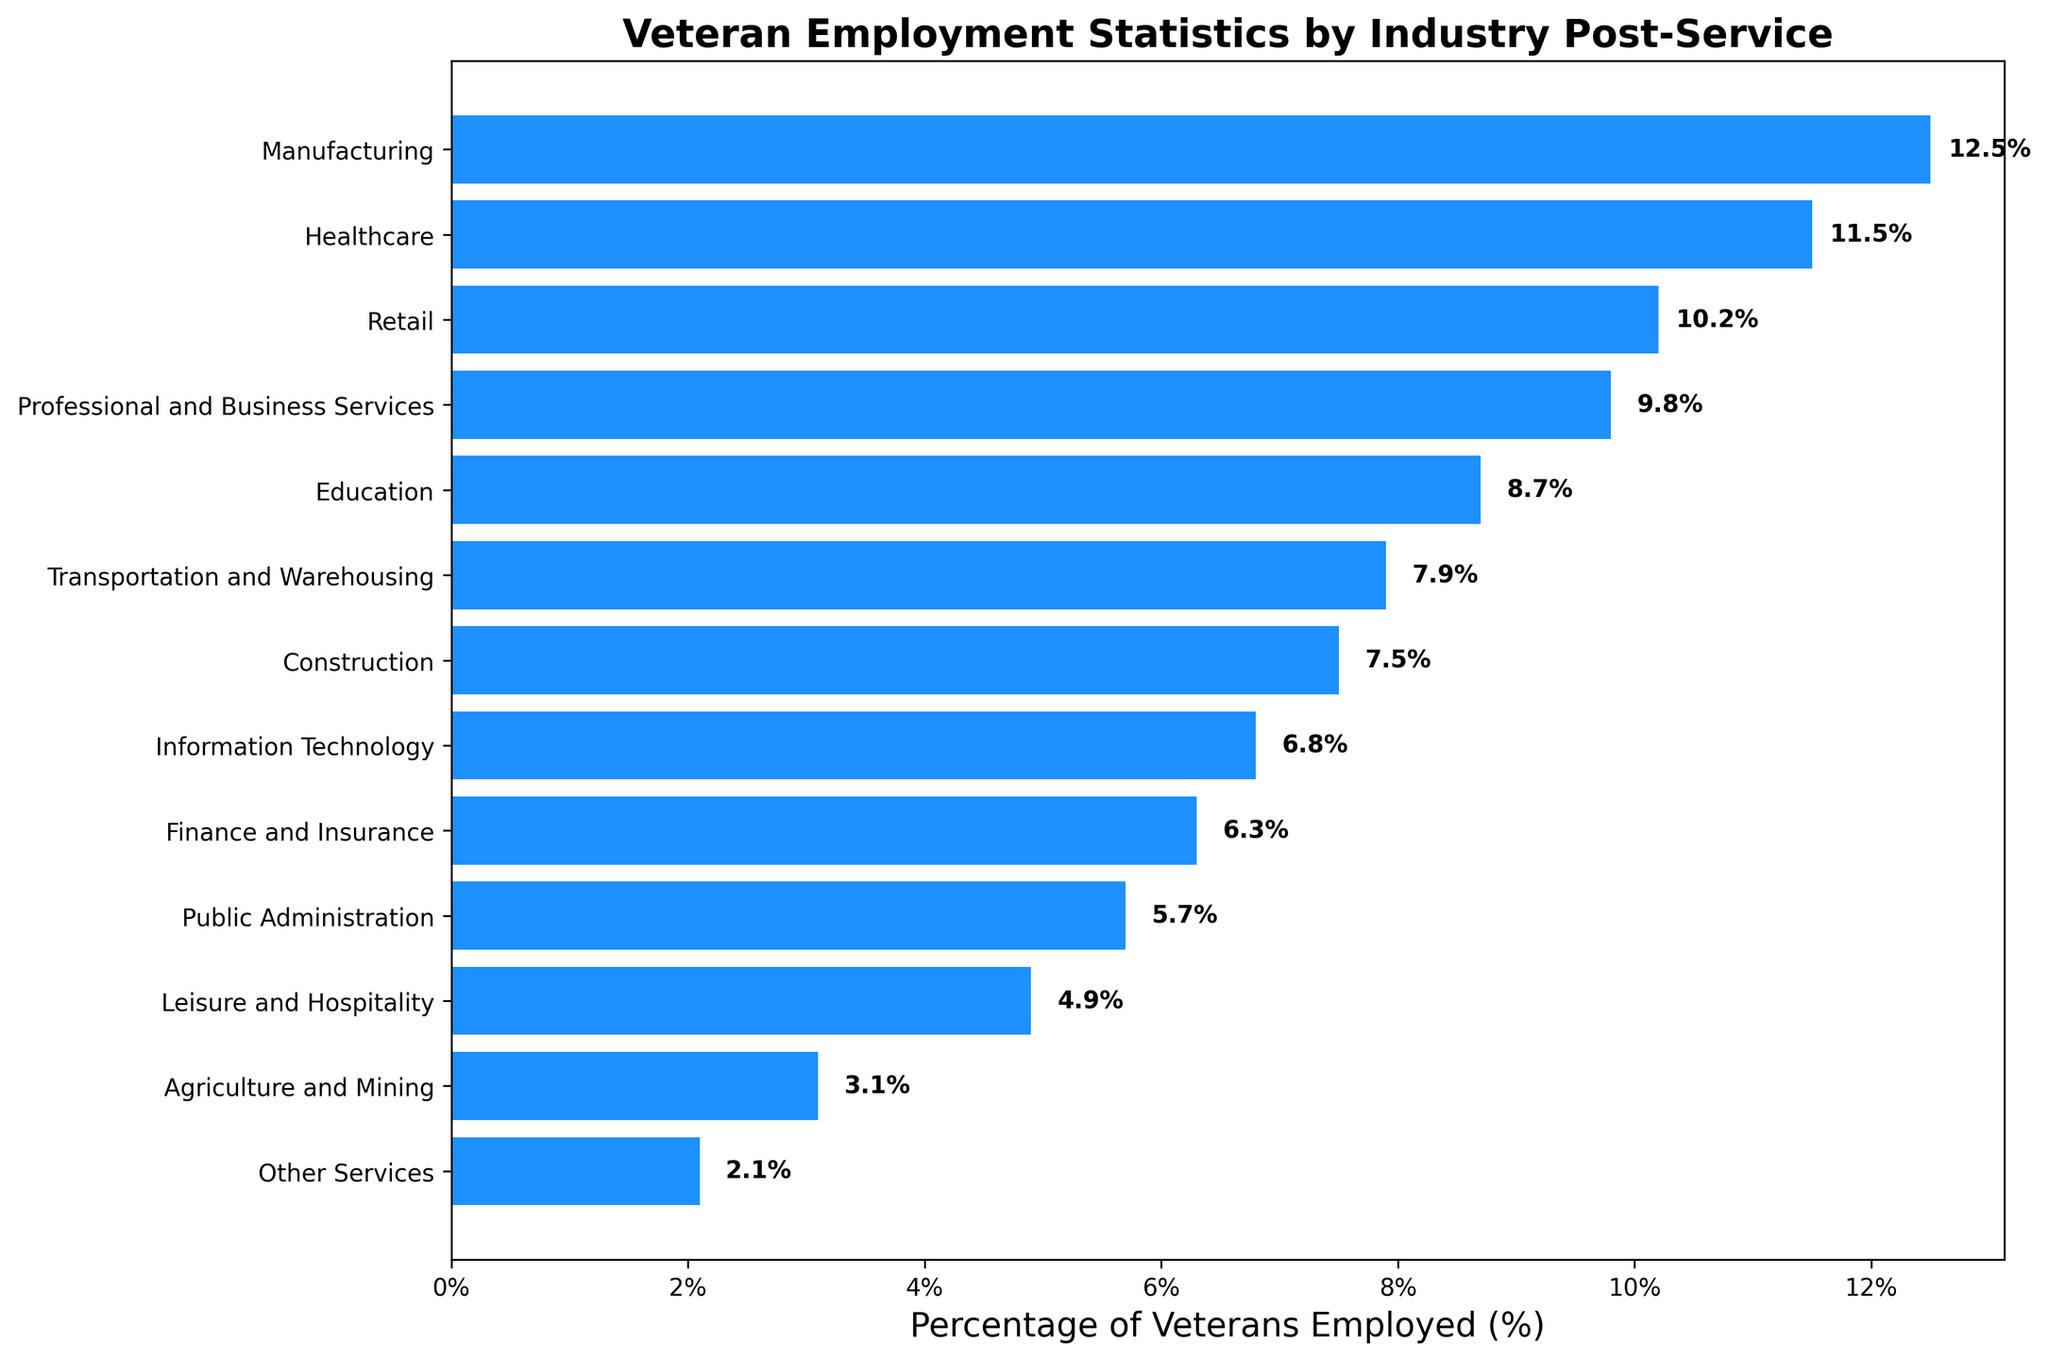What is the industry with the highest percentage of veterans employed? The bar with the greatest width indicates the industry with the highest percentage of veterans employed. The first bar from the top in the sorted chart represents "Manufacturing"
Answer: Manufacturing Which industries have more than 10% of veterans employed? Identify the bars whose percentages are greater than 10%. This includes those representing Manufacturing, Healthcare, and Retail
Answer: Manufacturing, Healthcare, Retail What is the combined percentage of veterans employed in Education and Construction? Add the percentages of Education (8.7%) and Construction (7.5%). 8.7 + 7.5 = 16.2
Answer: 16.2% Which industry has almost half the employment percentage of the Transportation and Warehousing industry? Find the Transportation and Warehousing percentage (7.9%) and look for an industry with approximately half this value. Public Administration (5.7%) fits this condition
Answer: Public Administration What is the difference in employment percentage between the highest and lowest industries? Subtract the percentage of the lowest industry “Other Services” (2.1%) from the highest “Manufacturing” (12.5%). 12.5 - 2.1 = 10.4
Answer: 10.4% Which industry is positioned exactly in the middle of the sorted chart of veteran employment percentages? Count the total number of industries (13) and identify the middle one, which would be the 7th one. This is Construction
Answer: Construction How many industries have less than 5% of veteran employment? Identify the bars with percentages less than 5%. These industries are Leisure and Hospitality, Agriculture and Mining, and Other Services. Count these bars
Answer: 3 What is the average employment percentage of Finance and Insurance and Information Technology? Add the percentages of Finance and Insurance (6.3%) and Information Technology (6.8%), then divide by 2. (6.3 + 6.8) / 2 = 6.55
Answer: 6.55% What is the visual difference between the bar representing Professional and Business Services and the bar representing Retail? Visually, the bar for Retail (10.2%) extends further to the right compared to the bar for Professional and Business Services (9.8%), indicating a larger employment percentage
Answer: Retail has a longer bar than Professional and Business Services Is the percentage of veterans employed in Public Administration closer to Leisure and Hospitality or Transportation and Warehousing? Compare the difference between Public Administration (5.7%) and both Leisure and Hospitality (4.9%) and Transportation and Warehousing (7.9%). 5.7 - 4.9 = 0.8, and 7.9 - 5.7 = 2.2, indicating Public Administration is closer to Leisure and Hospitality
Answer: Leisure and Hospitality 